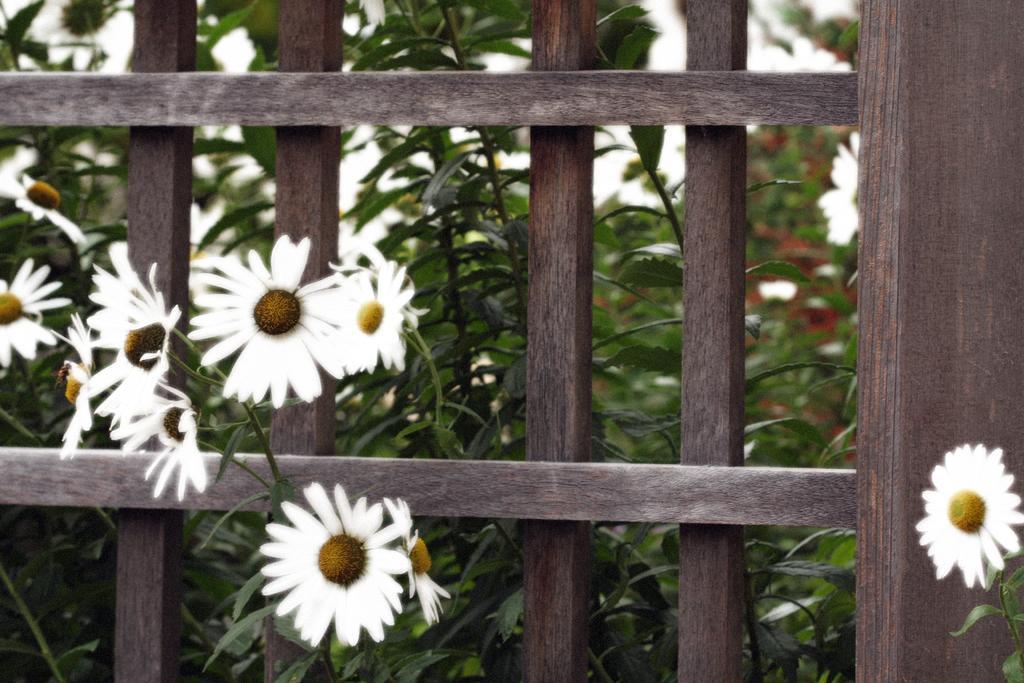Please provide a concise description of this image. In this image, we can see plants with flowers and there is a fence. 